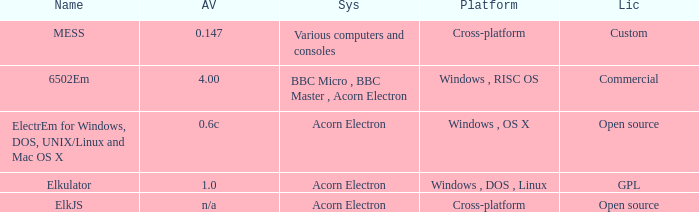Could you help me parse every detail presented in this table? {'header': ['Name', 'AV', 'Sys', 'Platform', 'Lic'], 'rows': [['MESS', '0.147', 'Various computers and consoles', 'Cross-platform', 'Custom'], ['6502Em', '4.00', 'BBC Micro , BBC Master , Acorn Electron', 'Windows , RISC OS', 'Commercial'], ['ElectrEm for Windows, DOS, UNIX/Linux and Mac OS X', '0.6c', 'Acorn Electron', 'Windows , OS X', 'Open source'], ['Elkulator', '1.0', 'Acorn Electron', 'Windows , DOS , Linux', 'GPL'], ['ElkJS', 'n/a', 'Acorn Electron', 'Cross-platform', 'Open source']]} What is the arrangement designated as elkjs? Acorn Electron. 